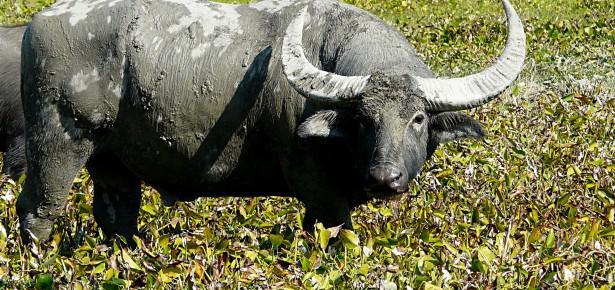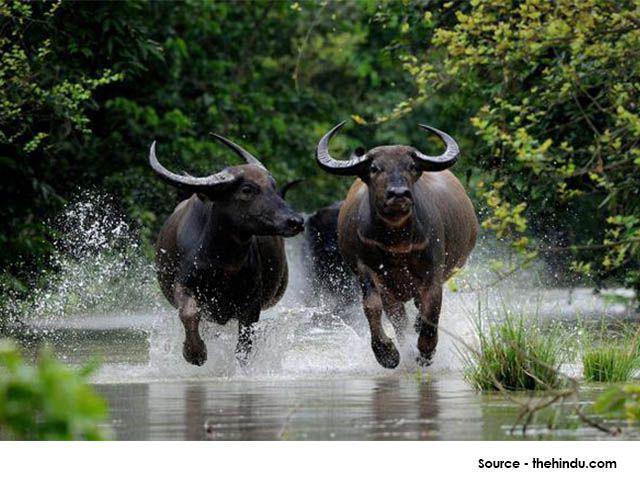The first image is the image on the left, the second image is the image on the right. For the images displayed, is the sentence "There are 3 water buffalos shown." factually correct? Answer yes or no. Yes. 